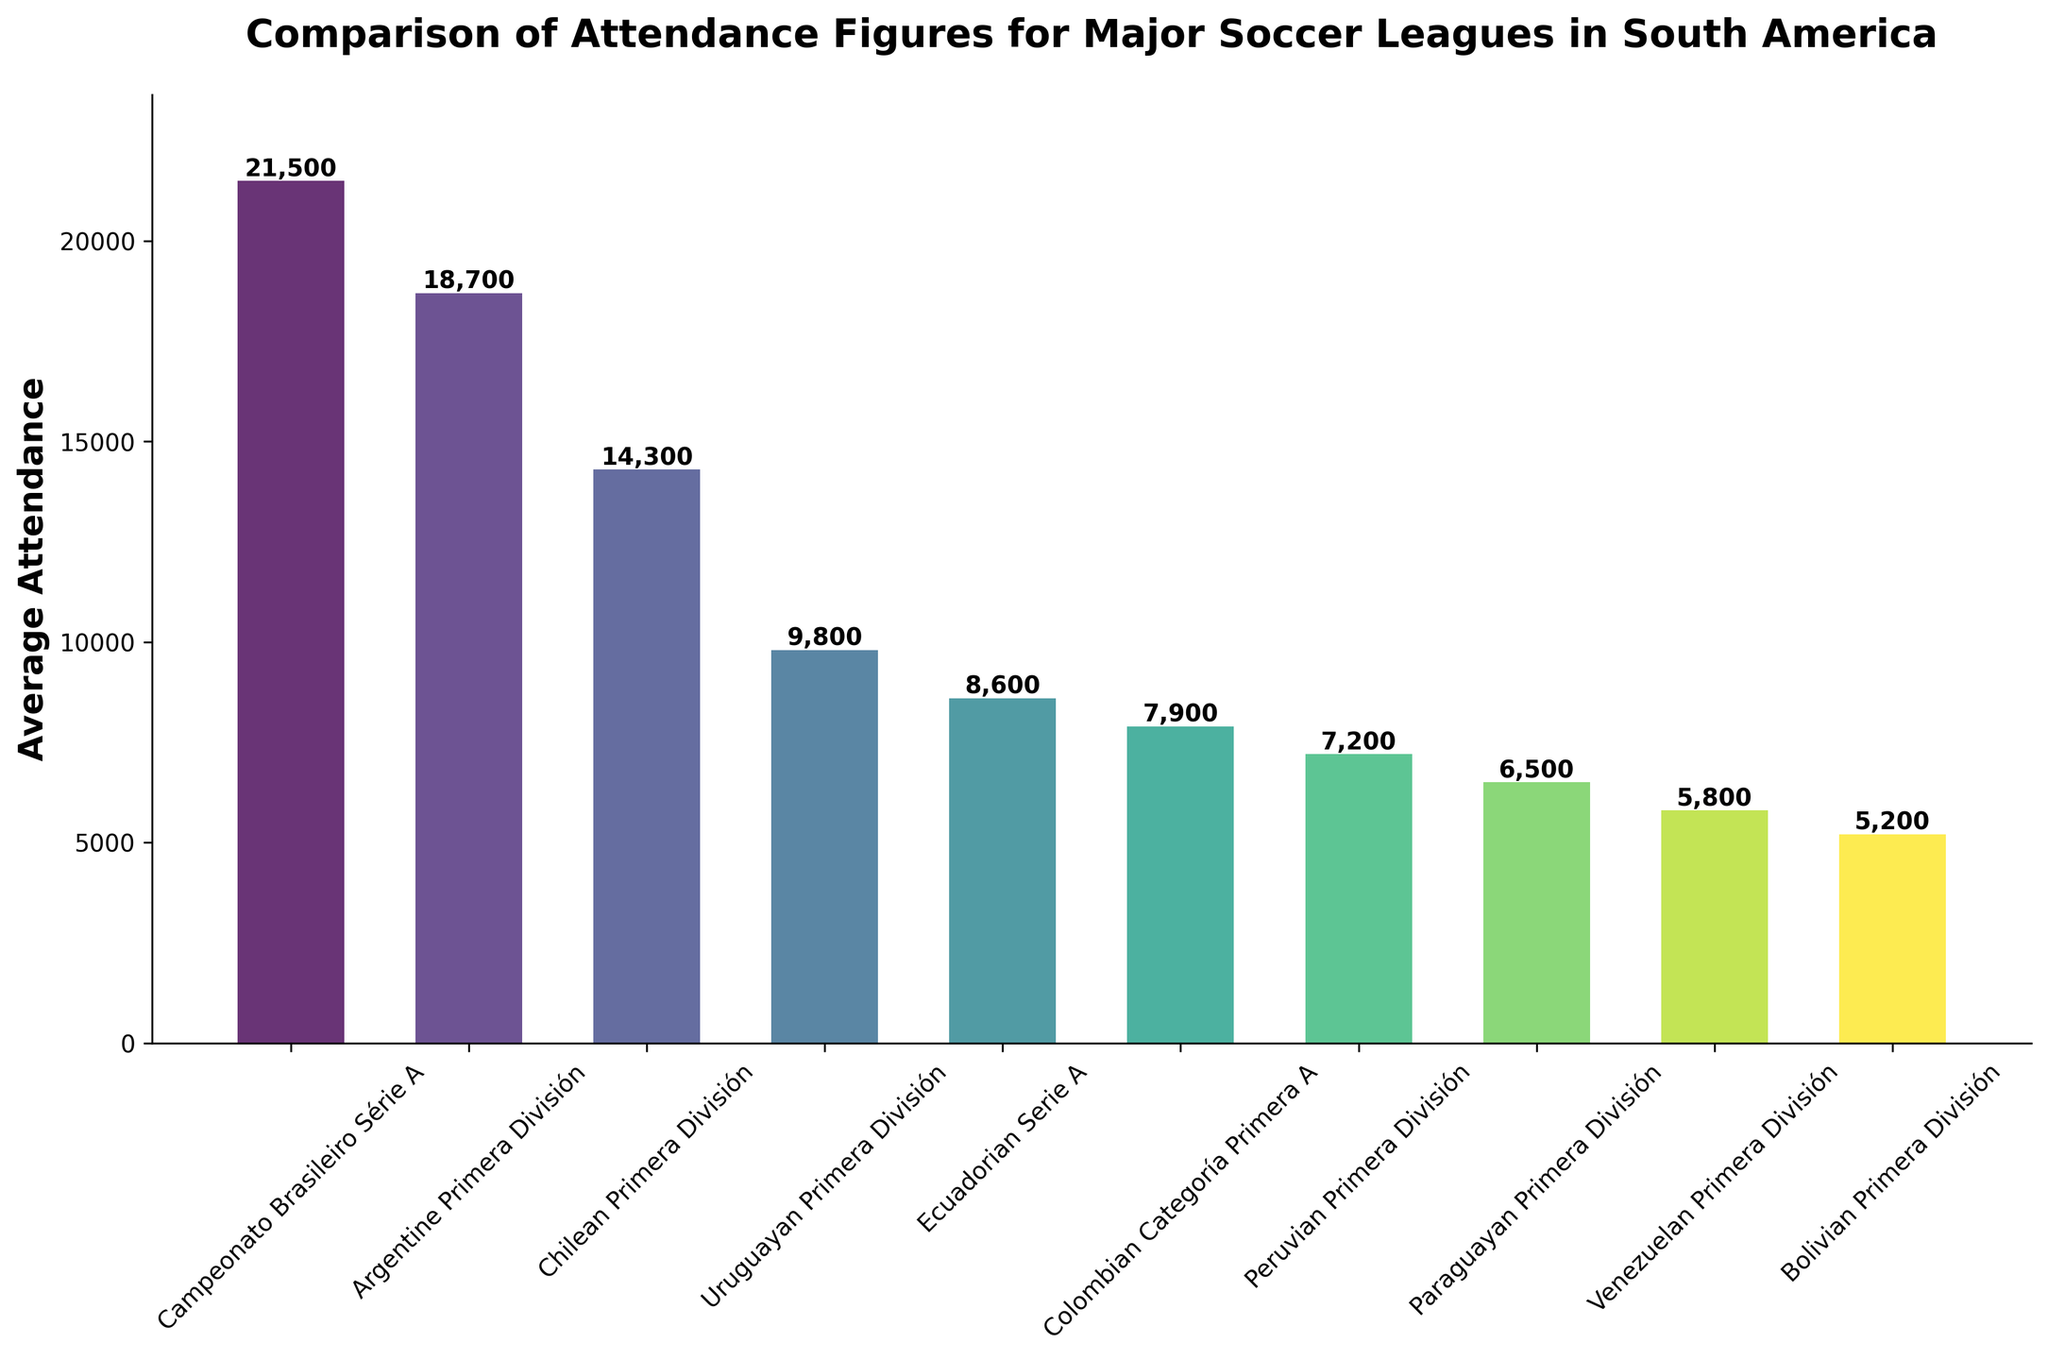What's the league with the highest average attendance? The tallest bar represents the league with the highest average attendance. In the figure, the Campeonato Brasileiro Série A has the highest bar.
Answer: Campeonato Brasileiro Série A How much higher is the average attendance of the Argentine Primera División compared to the Uruguayan Primera División? Compare the heights of the bars for the Argentine Primera División and the Uruguayan Primera División. The difference is 18,700 - 9,800.
Answer: 8,900 Which league has a lower average attendance: the Chilean Primera División or the Ecuadorian Serie A? Compare the heights of the bars for the Chilean Primera División and the Ecuadorian Serie A. The Chilean Primera División has a higher bar.
Answer: Ecuadorian Serie A What is the sum of the average attendances for the Colombian Categoría Primera A and the Peruvian Primera División? Look at the heights of the bars for the Colombian Categoría Primera A and the Peruvian Primera División and add them together: 7,900 + 7,200.
Answer: 15,100 What position does the Paraguayan Primera División hold in terms of average attendance ranking? Order the leagues by the height of their bars from highest to lowest. The Paraguayan Primera División holds the 8th position.
Answer: 8th Is the average attendance of the Venezuelan Primera División more than double that of the Bolivian Primera División? Compare the average attendance of the Venezuelan Primera División (5,800) with double the average attendance of the Bolivian Primera División (2 * 5,200 = 10,400). 5,800 is less than 10,400.
Answer: No How many leagues have an average attendance greater than 15,000? Count the number of bars with heights above 15,000. There are three leagues: Campeonato Brasileiro Série A, Argentine Primera División, and Chilean Primera División.
Answer: 3 What is the difference between the highest and lowest average attendances? Look at the heights of the bars for the highest and lowest average attendances: 21,500 (Campeonato Brasileiro Série A) - 5,200 (Bolivian Primera División).
Answer: 16,300 Which leagues have an average attendance between 5,000 and 10,000? Identify the bars with heights falling within the range of 5,000 to 10,000. These leagues are the Uruguayan Primera División, Ecuadorian Serie A, Colombian Categoría Primera A, Peruvian Primera División, Paraguayan Primera División, and Venezuelan Primera División.
Answer: Uruguayan Primera División, Ecuadorian Serie A, Colombian Categoría Primera A, Peruvian Primera División, Paraguayan Primera División, Venezuelan Primera División 